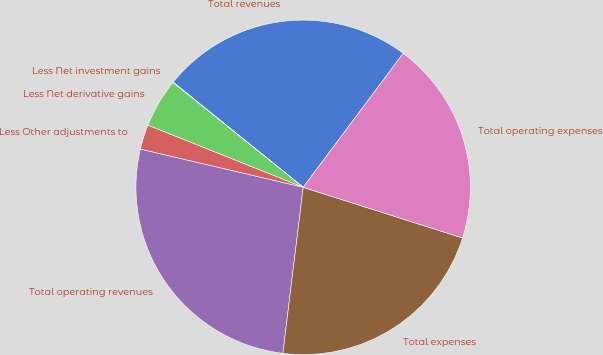Convert chart to OTSL. <chart><loc_0><loc_0><loc_500><loc_500><pie_chart><fcel>Total revenues<fcel>Less Net investment gains<fcel>Less Net derivative gains<fcel>Less Other adjustments to<fcel>Total operating revenues<fcel>Total expenses<fcel>Total operating expenses<nl><fcel>24.38%<fcel>0.04%<fcel>4.73%<fcel>2.39%<fcel>26.73%<fcel>22.04%<fcel>19.69%<nl></chart> 